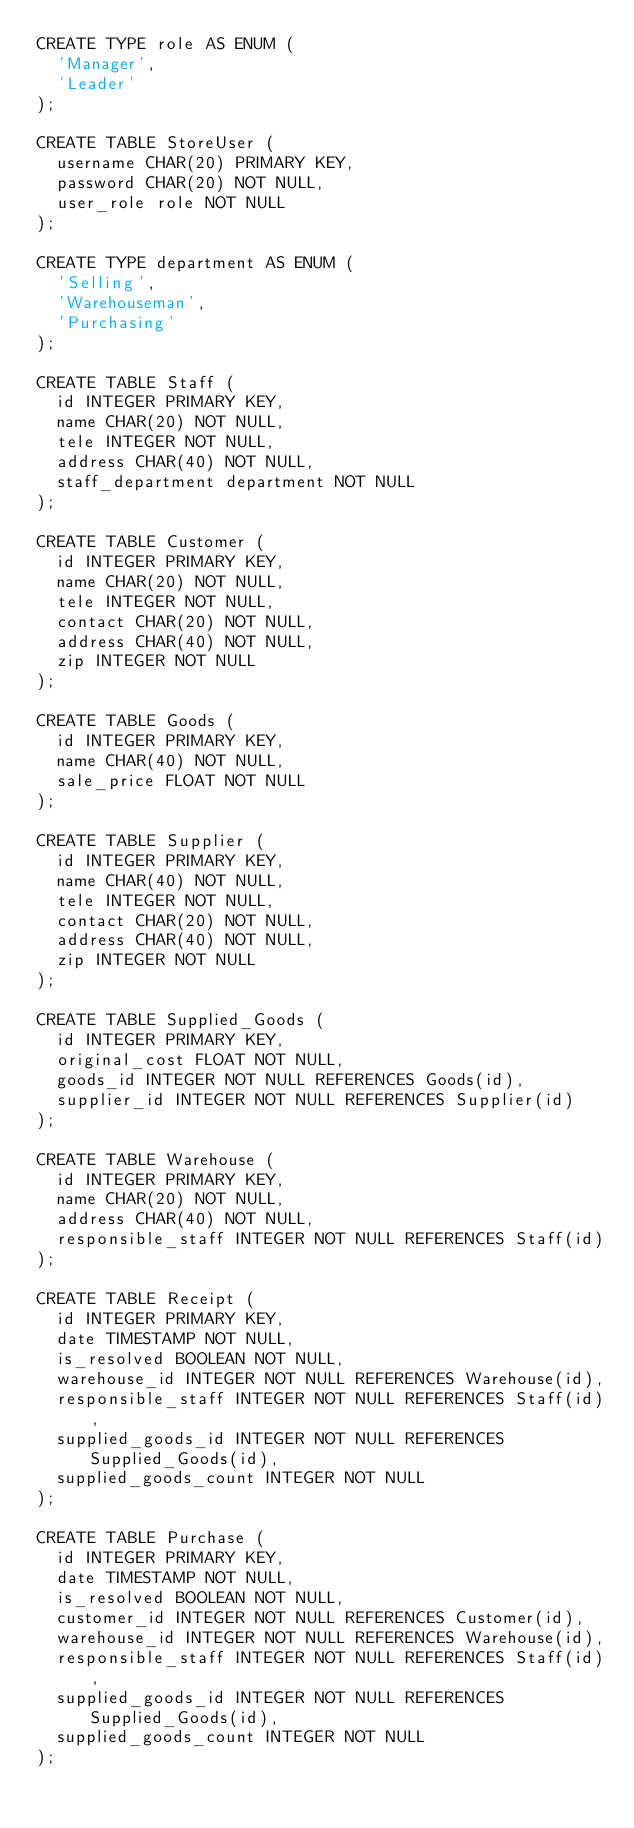<code> <loc_0><loc_0><loc_500><loc_500><_SQL_>CREATE TYPE role AS ENUM (
  'Manager',
  'Leader'
);

CREATE TABLE StoreUser (
  username CHAR(20) PRIMARY KEY,
  password CHAR(20) NOT NULL,
  user_role role NOT NULL
);

CREATE TYPE department AS ENUM (
  'Selling',
  'Warehouseman',
  'Purchasing'
);

CREATE TABLE Staff (
  id INTEGER PRIMARY KEY,
  name CHAR(20) NOT NULL,
  tele INTEGER NOT NULL,
  address CHAR(40) NOT NULL,
  staff_department department NOT NULL
);

CREATE TABLE Customer (
  id INTEGER PRIMARY KEY,
  name CHAR(20) NOT NULL,
  tele INTEGER NOT NULL,
  contact CHAR(20) NOT NULL,
  address CHAR(40) NOT NULL,
  zip INTEGER NOT NULL
);

CREATE TABLE Goods (
  id INTEGER PRIMARY KEY,
  name CHAR(40) NOT NULL,
  sale_price FLOAT NOT NULL
);

CREATE TABLE Supplier (
  id INTEGER PRIMARY KEY,
  name CHAR(40) NOT NULL,
  tele INTEGER NOT NULL,
  contact CHAR(20) NOT NULL,
  address CHAR(40) NOT NULL,
  zip INTEGER NOT NULL
);

CREATE TABLE Supplied_Goods (
  id INTEGER PRIMARY KEY,
  original_cost FLOAT NOT NULL,
  goods_id INTEGER NOT NULL REFERENCES Goods(id),
  supplier_id INTEGER NOT NULL REFERENCES Supplier(id)
);

CREATE TABLE Warehouse (
  id INTEGER PRIMARY KEY,
  name CHAR(20) NOT NULL,
  address CHAR(40) NOT NULL,
  responsible_staff INTEGER NOT NULL REFERENCES Staff(id)
);

CREATE TABLE Receipt (
  id INTEGER PRIMARY KEY,
  date TIMESTAMP NOT NULL,
  is_resolved BOOLEAN NOT NULL,
  warehouse_id INTEGER NOT NULL REFERENCES Warehouse(id),
  responsible_staff INTEGER NOT NULL REFERENCES Staff(id),
  supplied_goods_id INTEGER NOT NULL REFERENCES Supplied_Goods(id),
  supplied_goods_count INTEGER NOT NULL
);

CREATE TABLE Purchase (
  id INTEGER PRIMARY KEY,
  date TIMESTAMP NOT NULL,
  is_resolved BOOLEAN NOT NULL,
  customer_id INTEGER NOT NULL REFERENCES Customer(id),
  warehouse_id INTEGER NOT NULL REFERENCES Warehouse(id),
  responsible_staff INTEGER NOT NULL REFERENCES Staff(id),
  supplied_goods_id INTEGER NOT NULL REFERENCES Supplied_Goods(id),
  supplied_goods_count INTEGER NOT NULL
);
</code> 